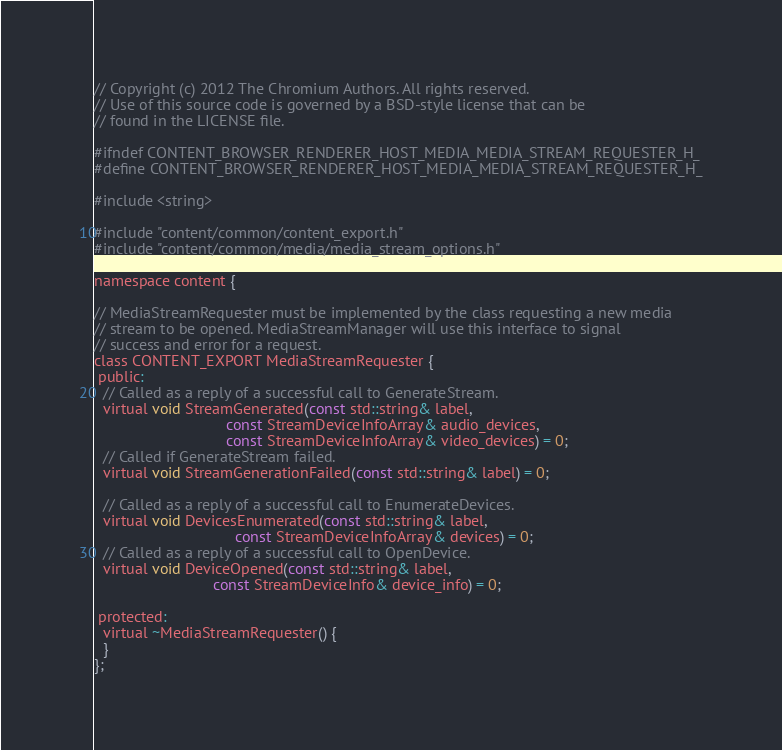Convert code to text. <code><loc_0><loc_0><loc_500><loc_500><_C_>// Copyright (c) 2012 The Chromium Authors. All rights reserved.
// Use of this source code is governed by a BSD-style license that can be
// found in the LICENSE file.

#ifndef CONTENT_BROWSER_RENDERER_HOST_MEDIA_MEDIA_STREAM_REQUESTER_H_
#define CONTENT_BROWSER_RENDERER_HOST_MEDIA_MEDIA_STREAM_REQUESTER_H_

#include <string>

#include "content/common/content_export.h"
#include "content/common/media/media_stream_options.h"

namespace content {

// MediaStreamRequester must be implemented by the class requesting a new media
// stream to be opened. MediaStreamManager will use this interface to signal
// success and error for a request.
class CONTENT_EXPORT MediaStreamRequester {
 public:
  // Called as a reply of a successful call to GenerateStream.
  virtual void StreamGenerated(const std::string& label,
                               const StreamDeviceInfoArray& audio_devices,
                               const StreamDeviceInfoArray& video_devices) = 0;
  // Called if GenerateStream failed.
  virtual void StreamGenerationFailed(const std::string& label) = 0;

  // Called as a reply of a successful call to EnumerateDevices.
  virtual void DevicesEnumerated(const std::string& label,
                                 const StreamDeviceInfoArray& devices) = 0;
  // Called as a reply of a successful call to OpenDevice.
  virtual void DeviceOpened(const std::string& label,
                            const StreamDeviceInfo& device_info) = 0;

 protected:
  virtual ~MediaStreamRequester() {
  }
};
</code> 